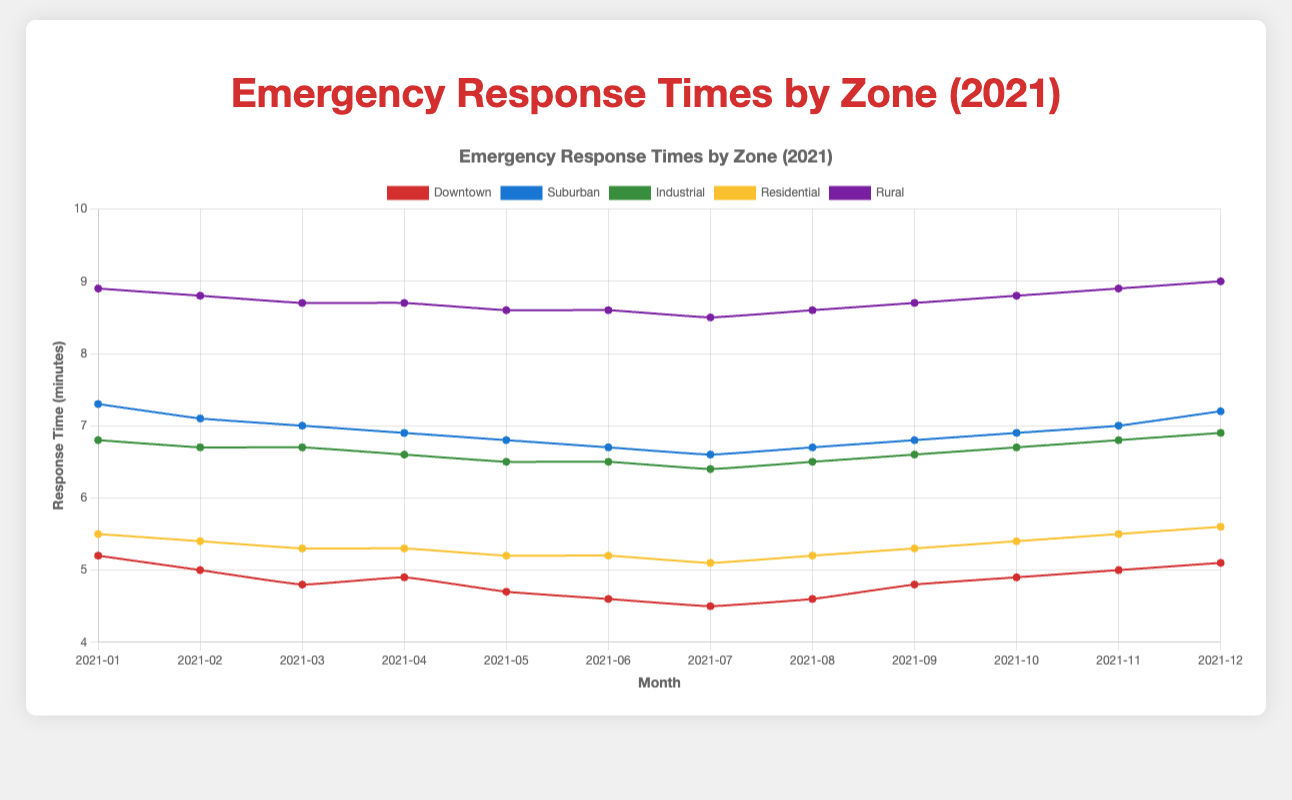What month had the shortest response time in the Downtown zone? By examining the line plot for the Downtown zone, we can identify the month with the lowest response time by finding the lowest point on the Downtown zone line. The shortest response time occurred in July 2021, with a response time of 4.5 minutes.
Answer: July 2021 Which zone had the highest response time in December 2021? To determine this, we need to compare the data points for December across all zones and identify the highest one. The highest response time in December 2021 was in the Rural zone, with a response time of 9.0 minutes.
Answer: Rural What is the difference in average response time between the Downtown and Suburban zones for the year 2021? Calculate the average response time for each zone over the 12 months, then find the difference. Downtown: (5.2+5.0+4.8+4.9+4.7+4.6+4.5+4.6+4.8+4.9+5.0+5.1)/12 = 4.85 minutes. Suburban: (7.3+7.1+7.0+6.9+6.8+6.7+6.6+6.7+6.8+6.9+7.0+7.2)/12 = 6.95 minutes. Difference: 6.95 - 4.85 = 2.1 minutes.
Answer: 2.1 minutes In which month did all zones have their highest combined average response time, and what was that average? Sum the response times for all zones for each month, then find the month with the highest total and calculate the average. The combined response time in November 2021 was highest (5.0 + 7.0 + 6.8 + 5.5 + 8.9 = 33.2). The average was 33.2/5 = 6.64 minutes.
Answer: November 2021, 6.64 minutes How does the trend in response times for the Downtown and Residential zones compare over the year 2021? Visually compare the line trends for both zones. Both zones show a general decline in response times from January to July, then a slight increase towards December.
Answer: Similar trend Which months show an increase in response times for the Suburban zone? Identify the months where the line for Suburban trends upward. The months with increases are August, October, November, and December.
Answer: August, October, November, December Are there any zones with constant response times during any month? Look for a segment in any zone's line where the response time does not change. The Industrial zone maintains a constant response time of 6.7 minutes during February and March, and the Residential zone maintains 5.3 minutes in March and April.
Answer: Industrial: February-March, Residential: March-April What is the overall trend for the Rural zone's response times over 2021? Examine the Rural zone's line throughout the year. The trend shows a slight decrease from January to July and then increases steadily from August to December.
Answer: Decrease then increase Which zone had the smallest change in response times from January to December 2021? Calculate the difference in response times from January and December for each zone and find the smallest change. Downtown: 5.2 - 5.1 = 0.1, Suburban: 7.3 - 7.2 = 0.1, Industrial: 6.8 - 6.9 = 0.1, Residential: 5.5 - 5.6 = -0.1, Rural: 8.9 - 9.0 = -0.1. Each zone had similar small changes, but Downtown had the smallest absolute change of 0.1.
Answer: Downtown, 0.1 minutes By how much did the response time for the Industrial zone change between August and September 2021? Locate the response times for the Industrial zone in August and September and subtract them. The response time changed from 6.5 to 6.6 minutes between August and September 2021, a change of 6.6 - 6.5 = 0.1 minutes.
Answer: 0.1 minutes 